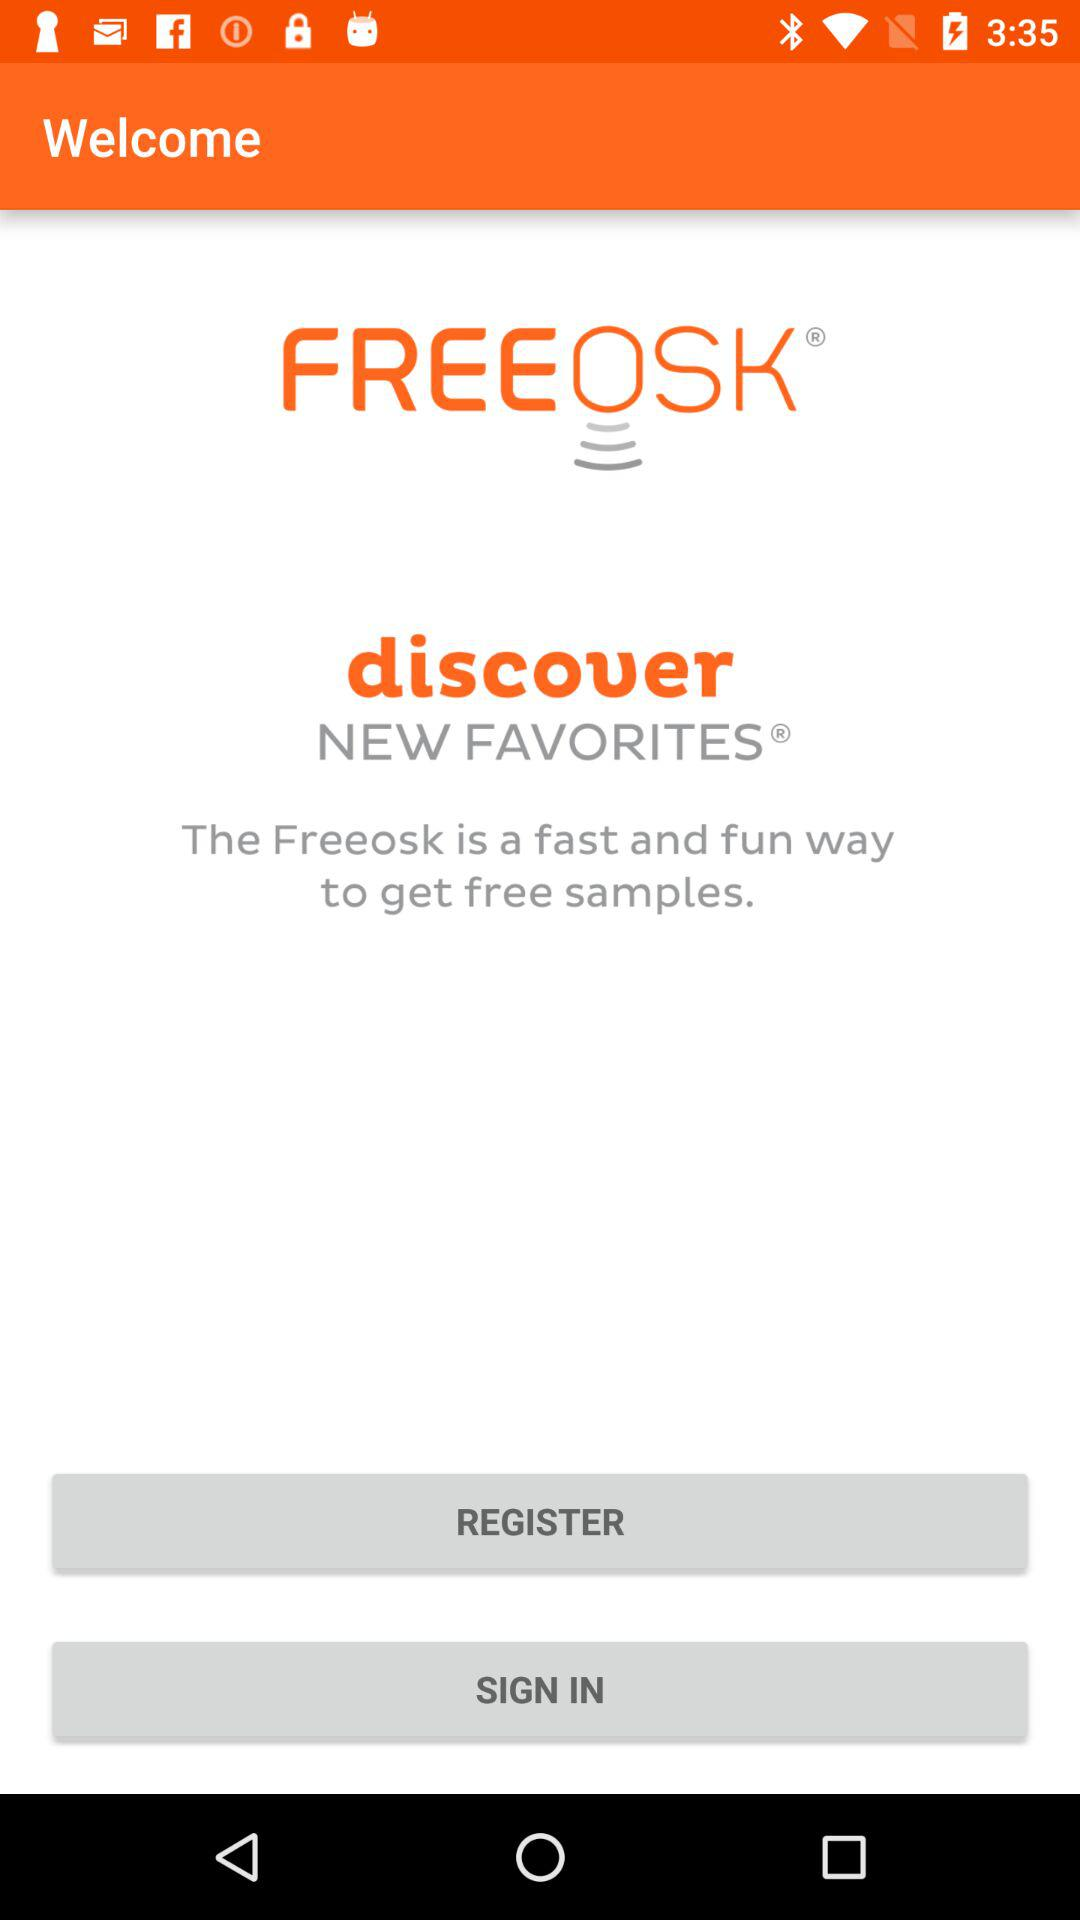What is the name of the application? The name of the application is "FREEOSK". 